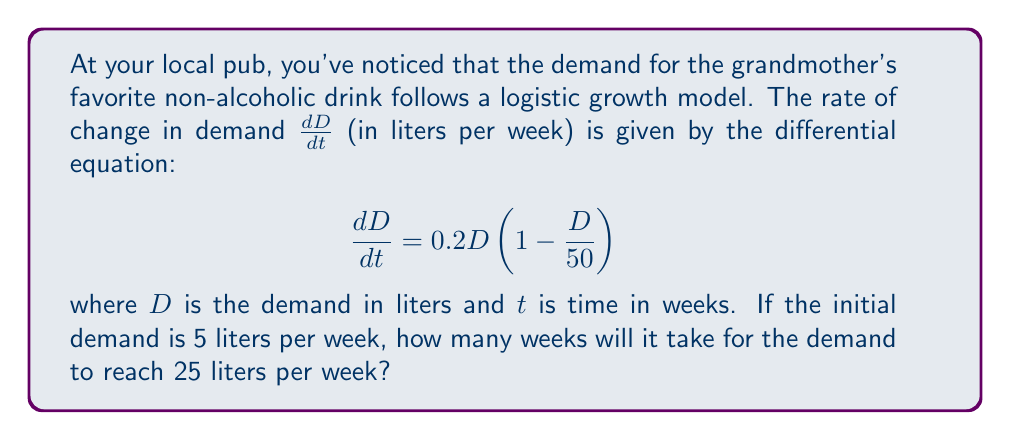Help me with this question. To solve this problem, we need to use the logistic growth model and separate variables to integrate:

1) First, rearrange the differential equation:
   $$\frac{dD}{0.2D(1 - \frac{D}{50})} = dt$$

2) Integrate both sides:
   $$\int \frac{dD}{0.2D(1 - \frac{D}{50})} = \int dt$$

3) The left-hand side can be integrated using partial fractions:
   $$\frac{1}{0.2} \int (\frac{1}{D} + \frac{1}{50-D}) dD = t + C$$

4) Evaluating the integral:
   $$\frac{1}{0.2} [\ln|D| - \ln|50-D|] = t + C$$

5) Simplify:
   $$5 \ln|\frac{D}{50-D}| = t + C$$

6) Apply the initial condition: At $t=0$, $D=5$:
   $$5 \ln|\frac{5}{45}| = C$$

7) Subtract this from the general solution:
   $$5 \ln|\frac{D}{50-D}| - 5 \ln|\frac{5}{45}| = t$$

8) Simplify:
   $$5 \ln|\frac{9D}{5(50-D)}| = t$$

9) Now, we want to find $t$ when $D=25$:
   $$5 \ln|\frac{9(25)}{5(50-25)}| = t$$

10) Evaluate:
    $$5 \ln|9| = t$$
    $$5 * 2.1972 = t$$
    $$10.986 \approx 11 \text{ weeks}$$
Answer: It will take approximately 11 weeks for the demand to reach 25 liters per week. 